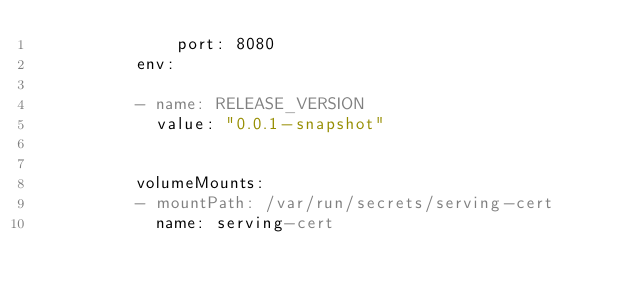Convert code to text. <code><loc_0><loc_0><loc_500><loc_500><_YAML_>              port: 8080
          env:
          
          - name: RELEASE_VERSION
            value: "0.0.1-snapshot"
          
          
          volumeMounts:
          - mountPath: /var/run/secrets/serving-cert
            name: serving-cert</code> 